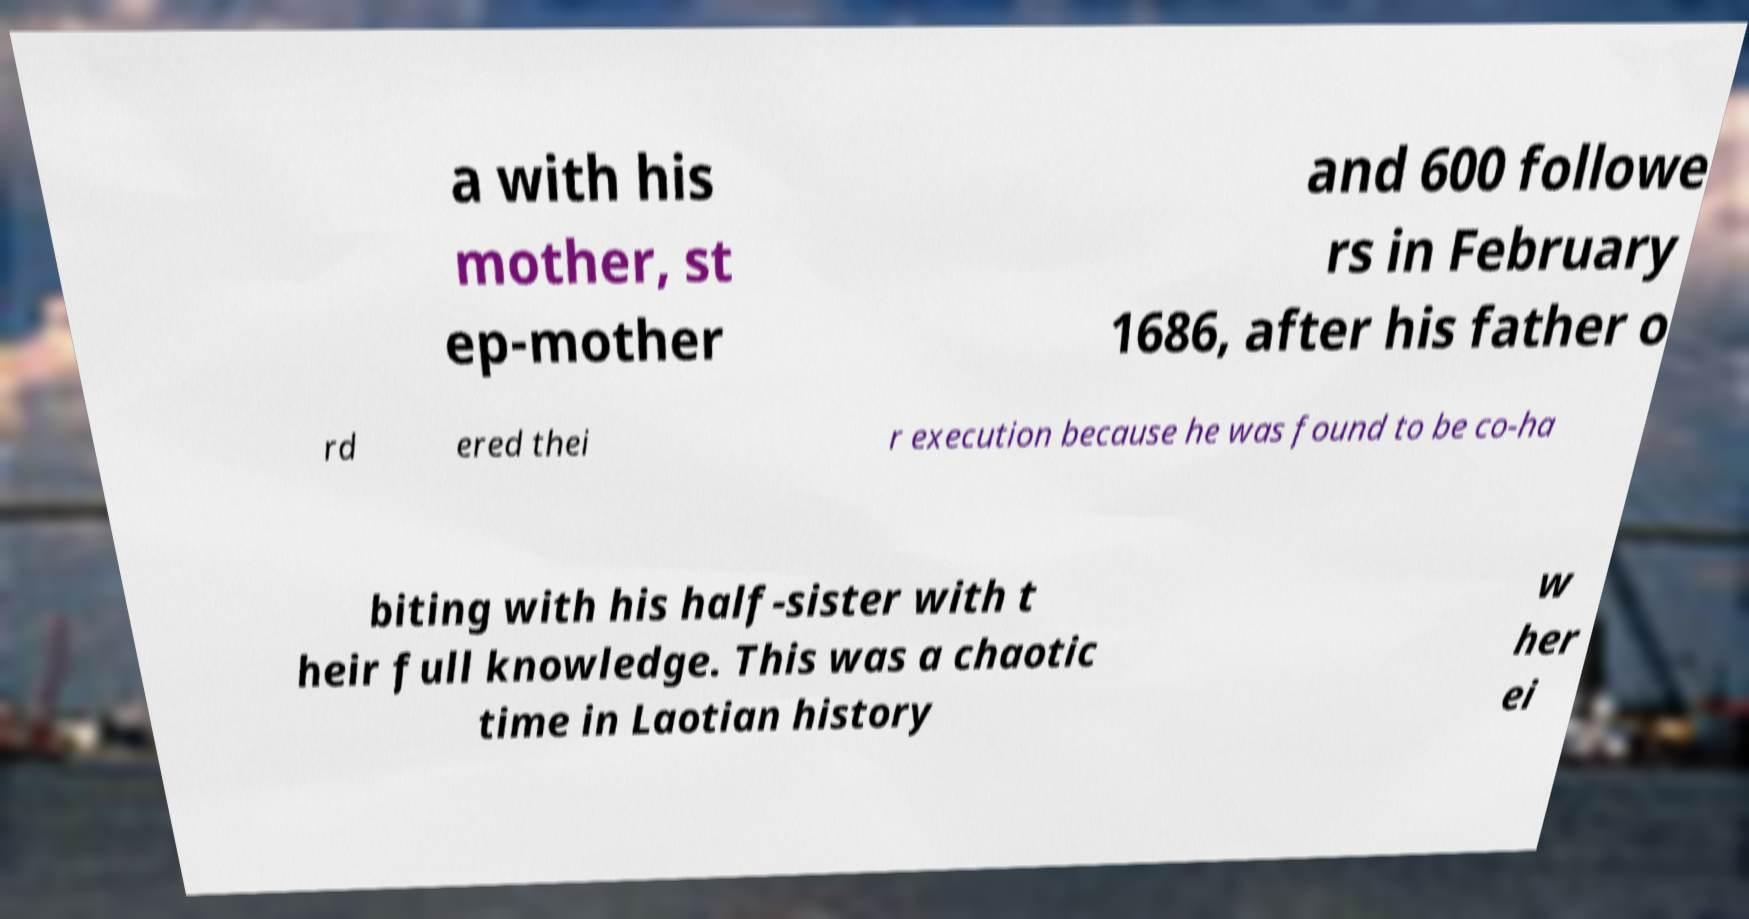I need the written content from this picture converted into text. Can you do that? a with his mother, st ep-mother and 600 followe rs in February 1686, after his father o rd ered thei r execution because he was found to be co-ha biting with his half-sister with t heir full knowledge. This was a chaotic time in Laotian history w her ei 